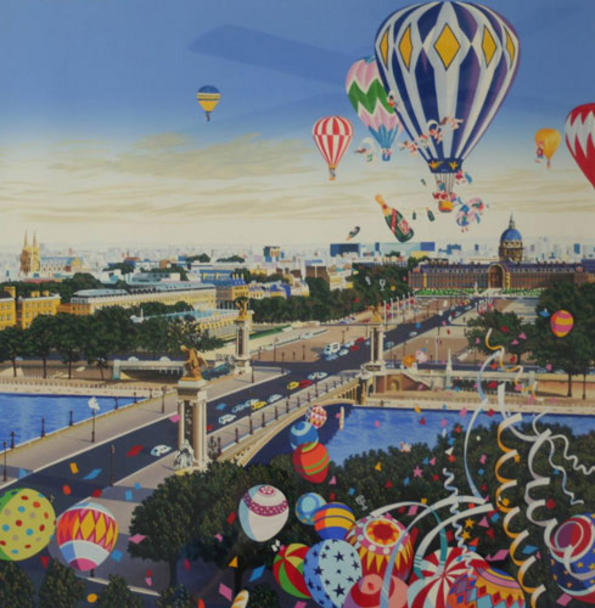If you could step into this artwork, what would you do first? If I could step into this artwork, the first thing I would do is join a hot air balloon festival. Experiencing the vibrant colors and designs up close, and perhaps even taking a ride in one of these whimsical balloons, would be an unforgettable adventure. I would then explore the surreal cityscape, wandering through the dreamlike streets and marveling at the imaginative architecture. Meeting the inhabitants and learning about their stories and traditions would offer a deeper understanding of this enchanting world. 